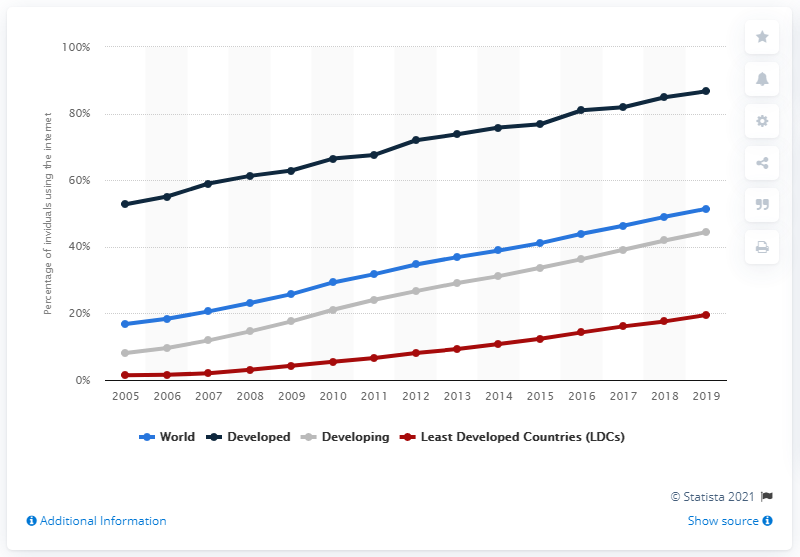Draw attention to some important aspects in this diagram. In 2019, the global online access rate was 51.4%. 